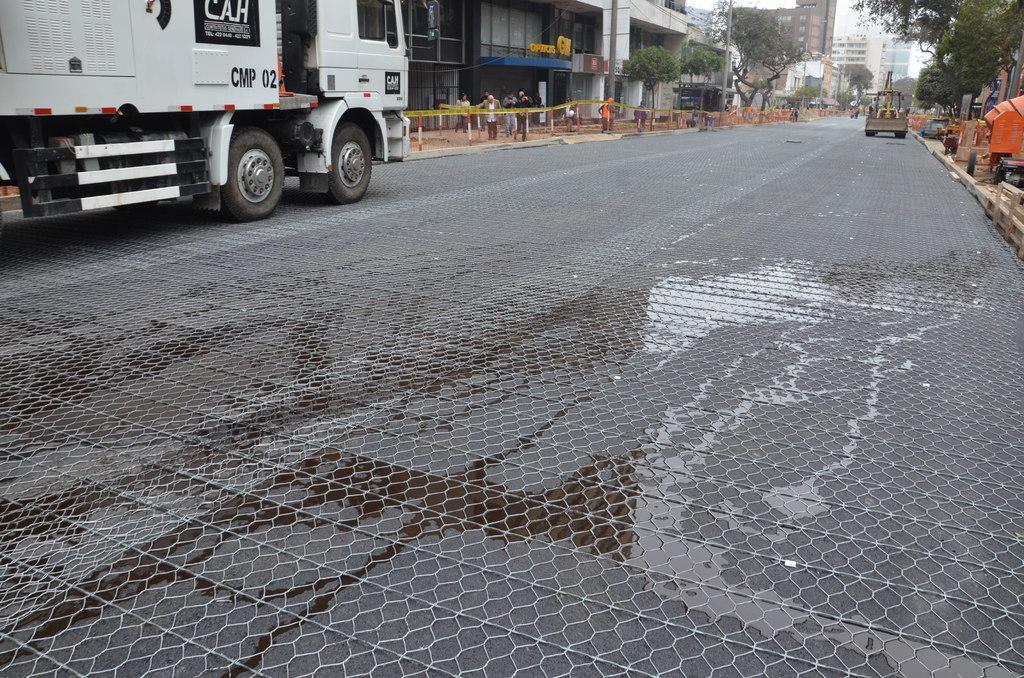Please provide a concise description of this image. In this image I can see a road in the centre and on it I can see few vehicles. In the background I can see few people are standing. I can also see few buildings and number of trees in the background. 